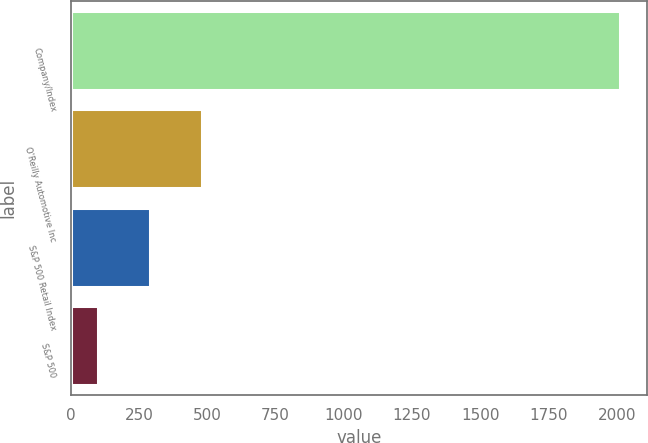<chart> <loc_0><loc_0><loc_500><loc_500><bar_chart><fcel>Company/Index<fcel>O'Reilly Automotive Inc<fcel>S&P 500 Retail Index<fcel>S&P 500<nl><fcel>2011<fcel>482.2<fcel>291.1<fcel>100<nl></chart> 